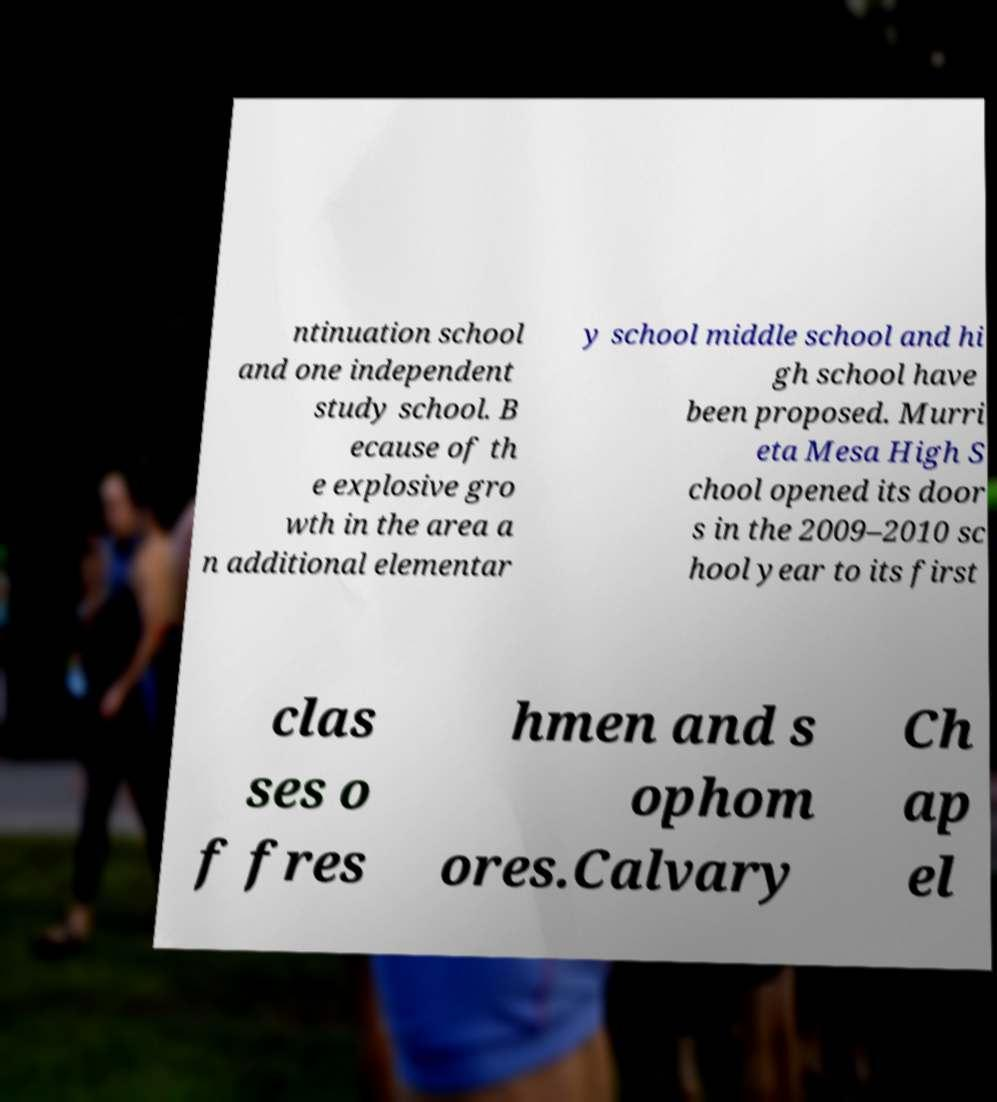Please identify and transcribe the text found in this image. ntinuation school and one independent study school. B ecause of th e explosive gro wth in the area a n additional elementar y school middle school and hi gh school have been proposed. Murri eta Mesa High S chool opened its door s in the 2009–2010 sc hool year to its first clas ses o f fres hmen and s ophom ores.Calvary Ch ap el 